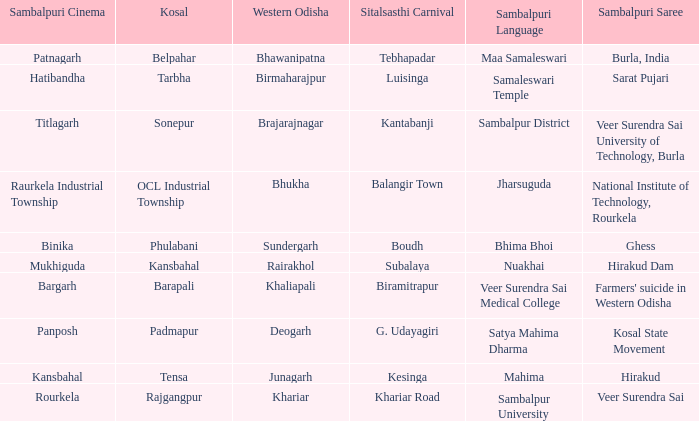What is the Kosal with a balangir town sitalsasthi carnival? OCL Industrial Township. 